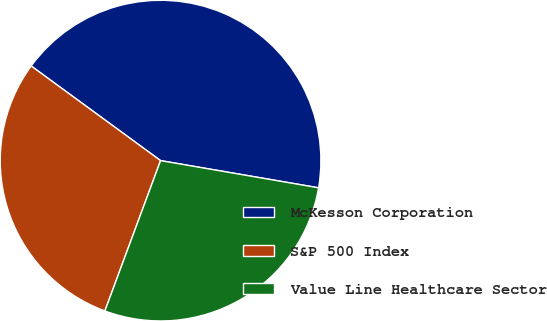Convert chart. <chart><loc_0><loc_0><loc_500><loc_500><pie_chart><fcel>McKesson Corporation<fcel>S&P 500 Index<fcel>Value Line Healthcare Sector<nl><fcel>42.66%<fcel>29.4%<fcel>27.93%<nl></chart> 